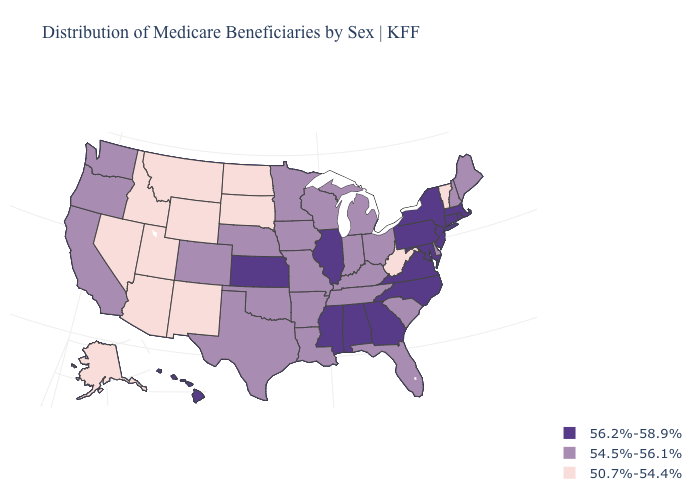Among the states that border Georgia , does Florida have the lowest value?
Be succinct. Yes. Name the states that have a value in the range 56.2%-58.9%?
Answer briefly. Alabama, Connecticut, Georgia, Hawaii, Illinois, Kansas, Maryland, Massachusetts, Mississippi, New Jersey, New York, North Carolina, Pennsylvania, Rhode Island, Virginia. Name the states that have a value in the range 54.5%-56.1%?
Be succinct. Arkansas, California, Colorado, Delaware, Florida, Indiana, Iowa, Kentucky, Louisiana, Maine, Michigan, Minnesota, Missouri, Nebraska, New Hampshire, Ohio, Oklahoma, Oregon, South Carolina, Tennessee, Texas, Washington, Wisconsin. What is the value of Ohio?
Short answer required. 54.5%-56.1%. Does New Hampshire have the same value as Idaho?
Short answer required. No. Name the states that have a value in the range 54.5%-56.1%?
Short answer required. Arkansas, California, Colorado, Delaware, Florida, Indiana, Iowa, Kentucky, Louisiana, Maine, Michigan, Minnesota, Missouri, Nebraska, New Hampshire, Ohio, Oklahoma, Oregon, South Carolina, Tennessee, Texas, Washington, Wisconsin. What is the value of Louisiana?
Concise answer only. 54.5%-56.1%. Does Alaska have the highest value in the USA?
Give a very brief answer. No. How many symbols are there in the legend?
Short answer required. 3. What is the value of Massachusetts?
Answer briefly. 56.2%-58.9%. What is the value of Alabama?
Write a very short answer. 56.2%-58.9%. Does Louisiana have the lowest value in the South?
Be succinct. No. What is the lowest value in the South?
Give a very brief answer. 50.7%-54.4%. Which states have the lowest value in the USA?
Short answer required. Alaska, Arizona, Idaho, Montana, Nevada, New Mexico, North Dakota, South Dakota, Utah, Vermont, West Virginia, Wyoming. Does Hawaii have a lower value than Virginia?
Concise answer only. No. 